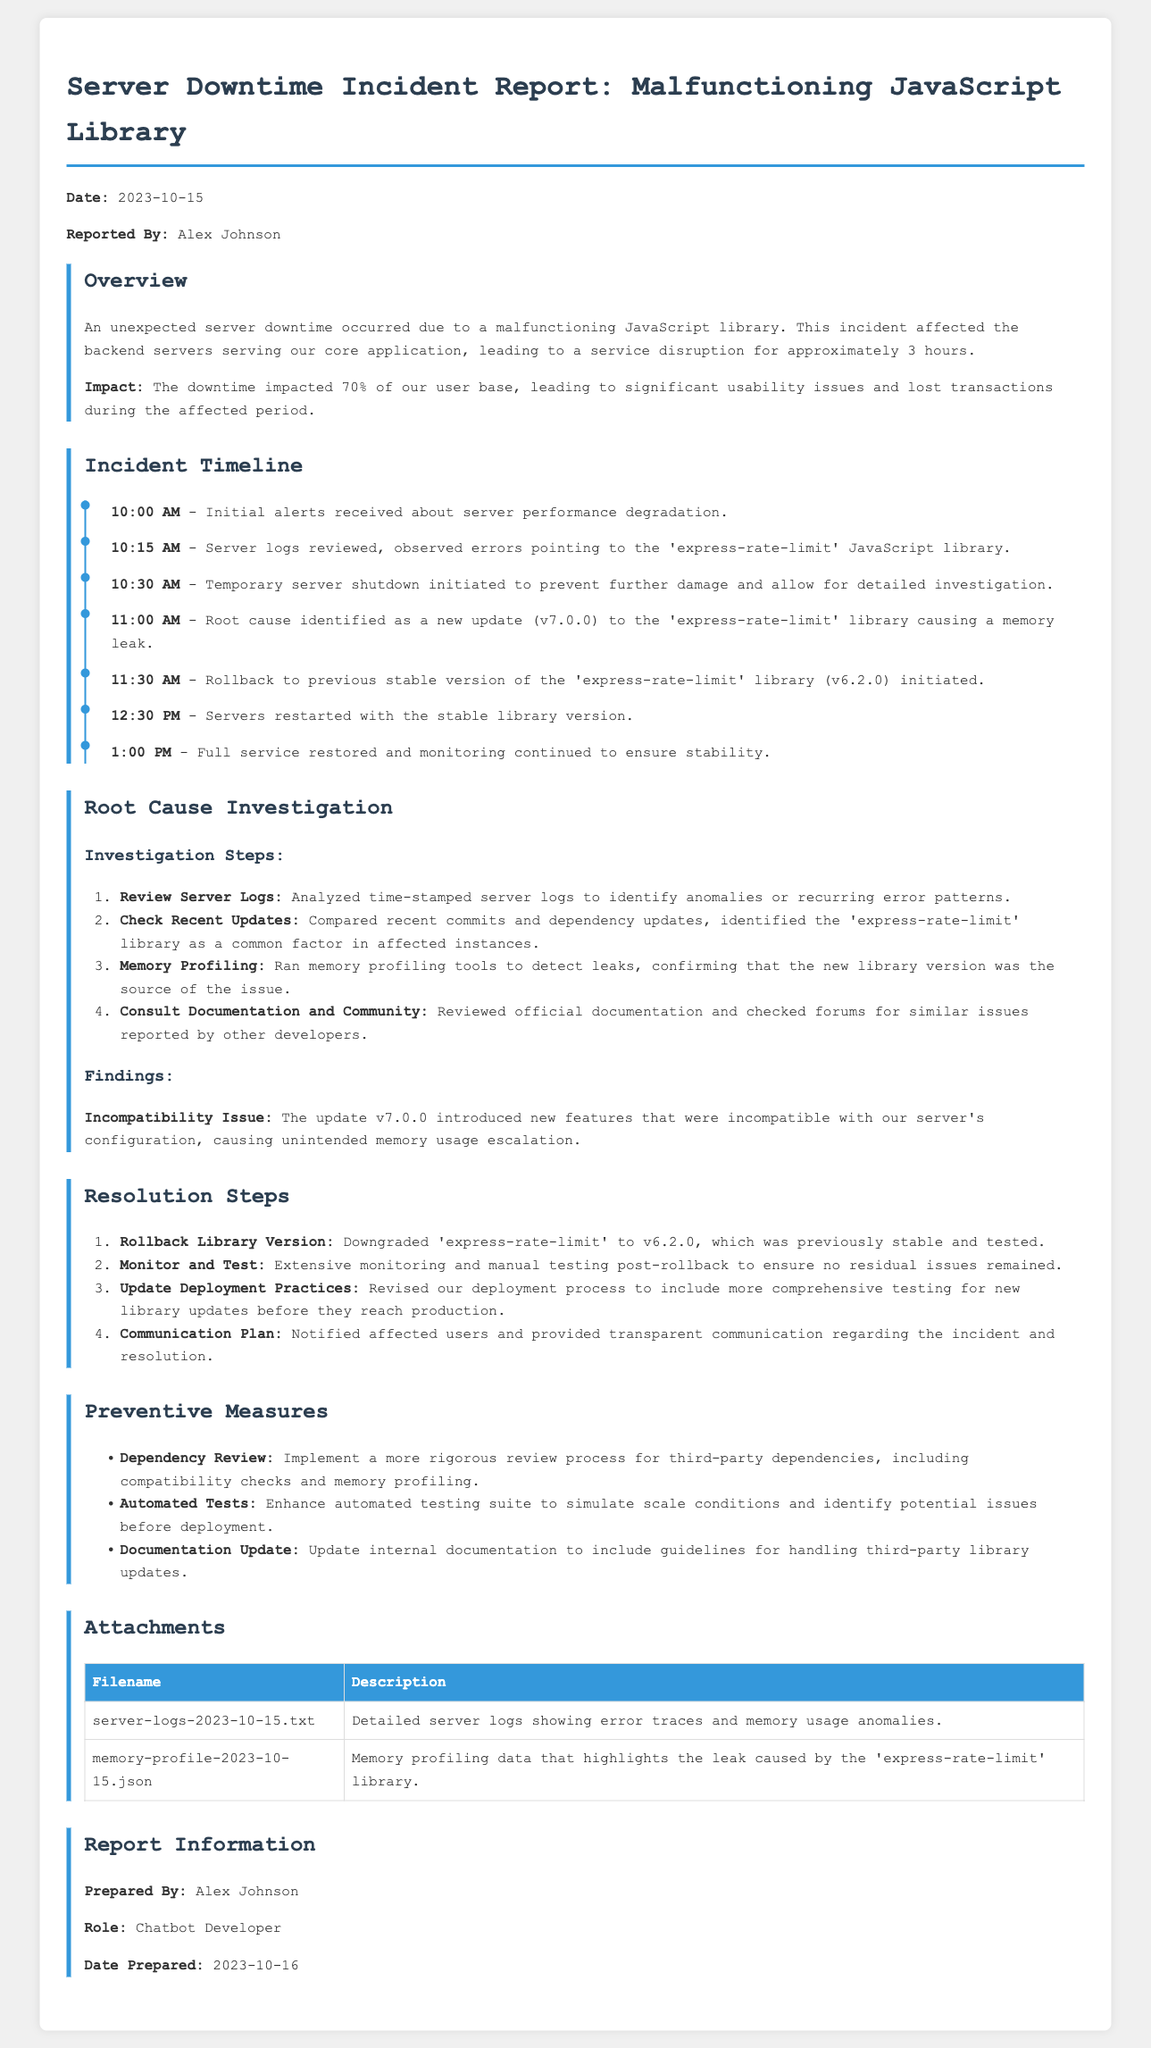What was the date of the incident? The incident occurred on October 15, 2023, as stated in the overview section of the report.
Answer: October 15, 2023 Who reported the incident? The report specifies that Alex Johnson was the one who reported the incident.
Answer: Alex Johnson What percentage of the user base was impacted? The overview indicates that 70% of the user base faced downtime during the incident.
Answer: 70% What caused the server downtime? The root cause was identified as a malfunctioning JavaScript library, specifically the 'express-rate-limit' library.
Answer: 'express-rate-limit' At what time was the rollback to the previous stable library version initiated? The incident timeline shows that the rollback was initiated at 11:30 AM.
Answer: 11:30 AM What was the new version of the 'express-rate-limit' library that caused the issues? The update that caused the server issues was version 7.0.0 of the library, as per the investigation findings.
Answer: v7.0.0 What is one preventive measure suggested in the report? The report lists several preventive measures, including implementing a more rigorous review process for third-party dependencies.
Answer: Dependency Review What was the total duration of the service disruption? The overview mentions that the service disruption lasted for approximately 3 hours.
Answer: 3 hours What document was prepared by Alex Johnson? The report indicates that Alex Johnson prepared the incident report itself.
Answer: Incident report 